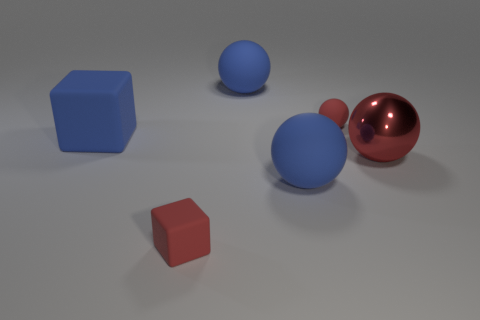Is there any other thing that has the same material as the large red thing?
Ensure brevity in your answer.  No. What is the material of the cube that is the same color as the metal object?
Ensure brevity in your answer.  Rubber. There is a rubber ball that is the same color as the metallic thing; what size is it?
Your answer should be very brief. Small. There is a big red metallic object; is its shape the same as the small red thing that is behind the large cube?
Offer a terse response. Yes. Are there any other shiny objects that have the same shape as the red shiny object?
Your response must be concise. No. What is the shape of the big object behind the small object on the right side of the small red block?
Give a very brief answer. Sphere. There is a tiny matte object in front of the shiny sphere; what shape is it?
Offer a very short reply. Cube. There is a tiny rubber thing that is on the right side of the small red matte block; does it have the same color as the big matte object to the left of the tiny cube?
Offer a very short reply. No. What number of large objects are right of the blue rubber cube and on the left side of the large red thing?
Provide a succinct answer. 2. What size is the red sphere that is the same material as the large blue cube?
Offer a terse response. Small. 